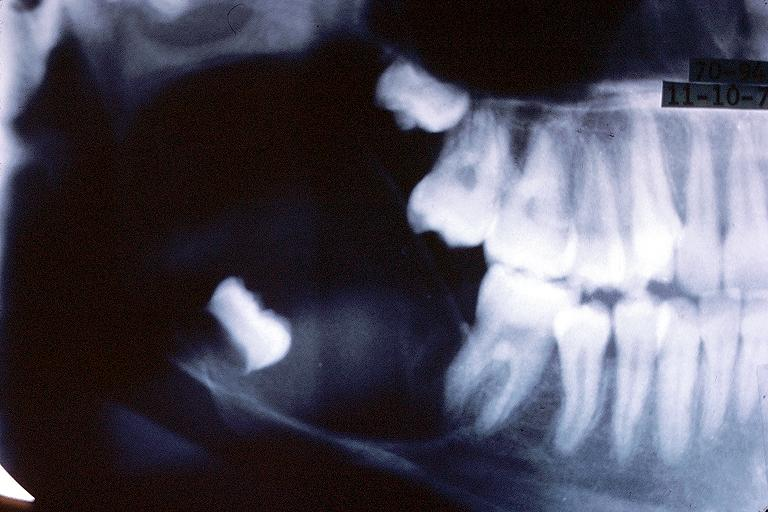what does this image show?
Answer the question using a single word or phrase. Unicystic ameloblastom 